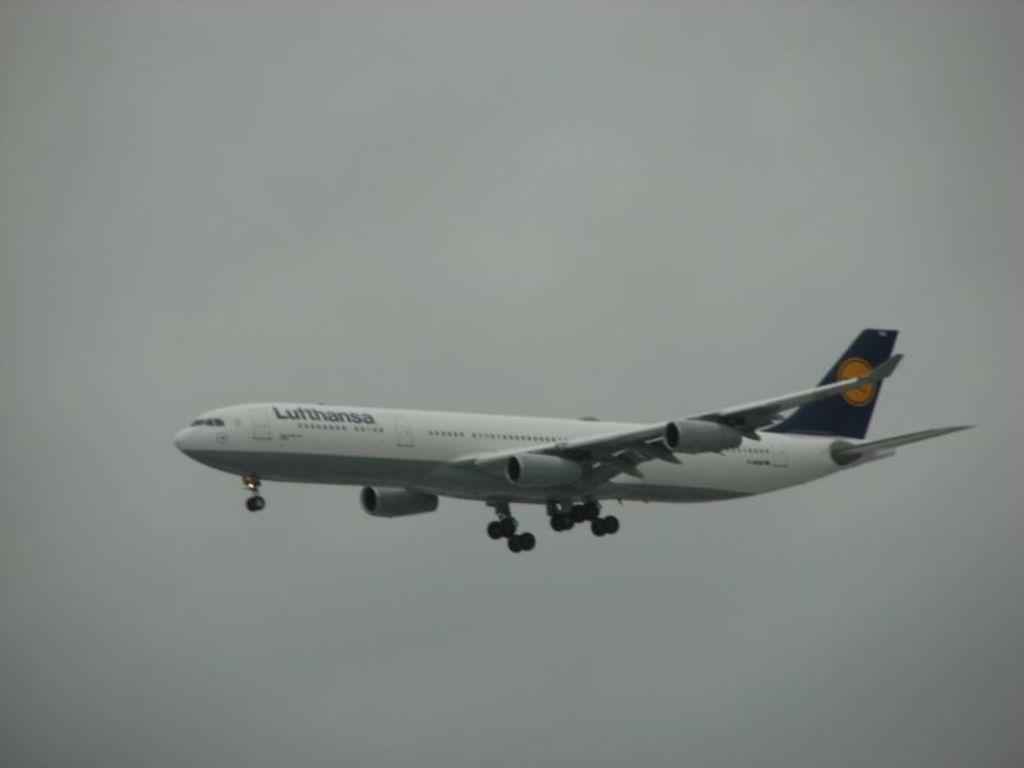In one or two sentences, can you explain what this image depicts? In this image I can see a flight. 